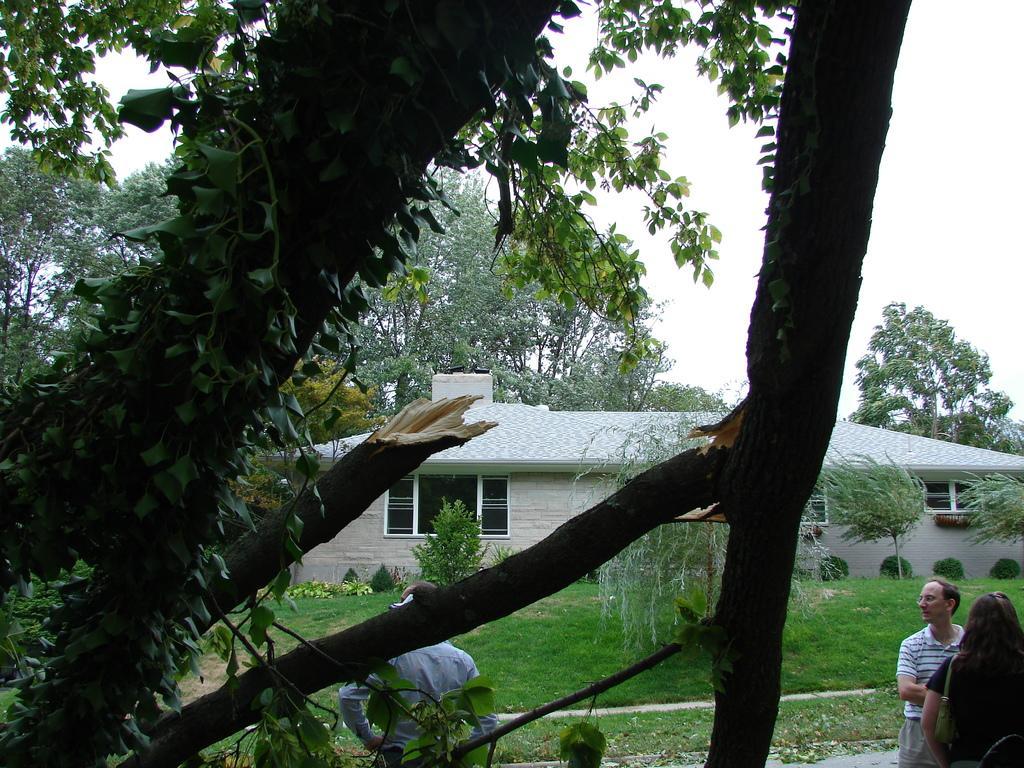In one or two sentences, can you explain what this image depicts? In this image we can see the tree trunk and branches. And we can see the house and the windows. And we can see a few people standing. And we can see the grass, trees. And we can see the sky. 